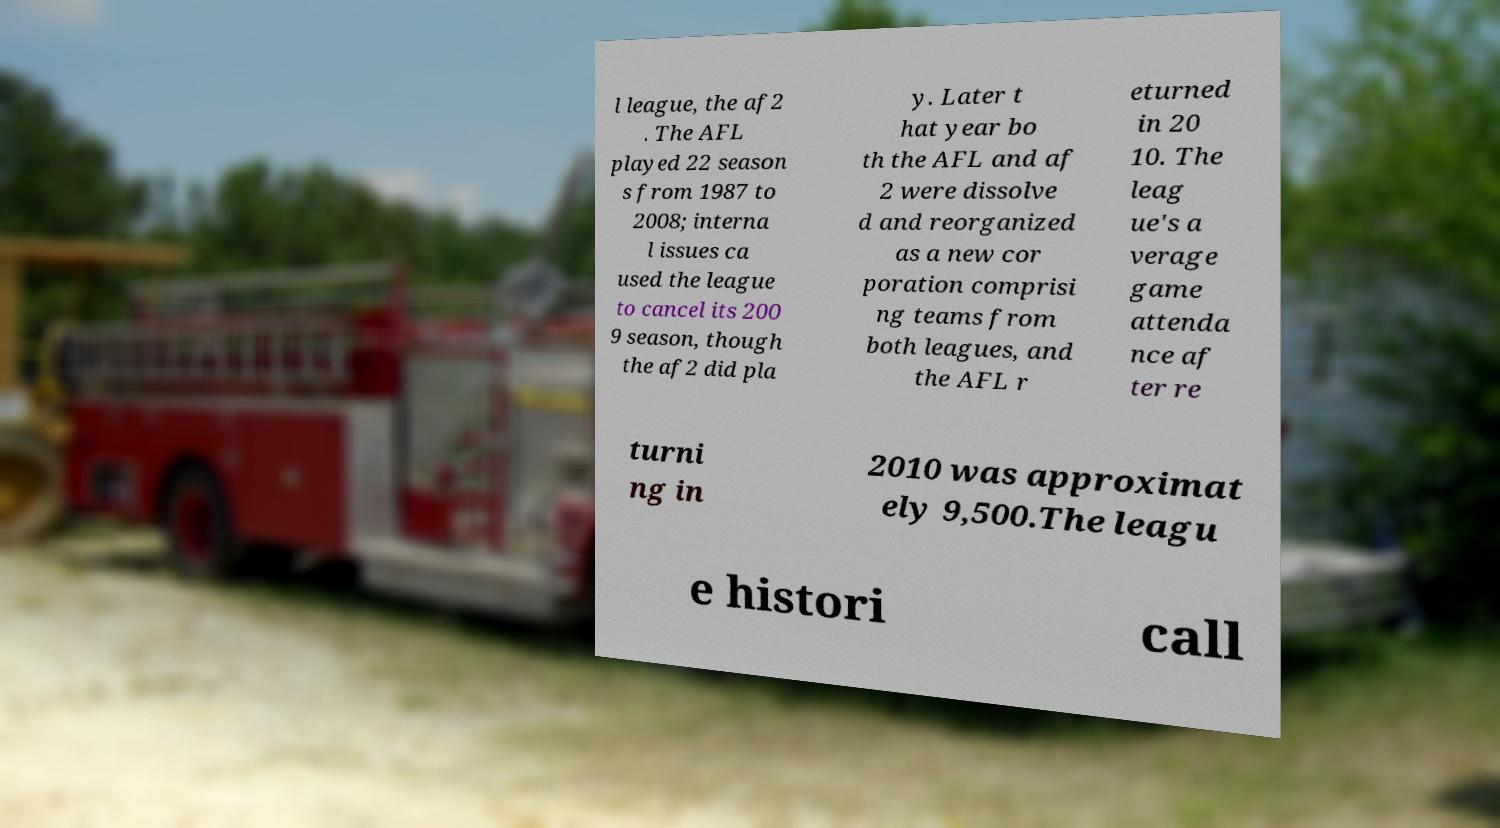What messages or text are displayed in this image? I need them in a readable, typed format. l league, the af2 . The AFL played 22 season s from 1987 to 2008; interna l issues ca used the league to cancel its 200 9 season, though the af2 did pla y. Later t hat year bo th the AFL and af 2 were dissolve d and reorganized as a new cor poration comprisi ng teams from both leagues, and the AFL r eturned in 20 10. The leag ue's a verage game attenda nce af ter re turni ng in 2010 was approximat ely 9,500.The leagu e histori call 